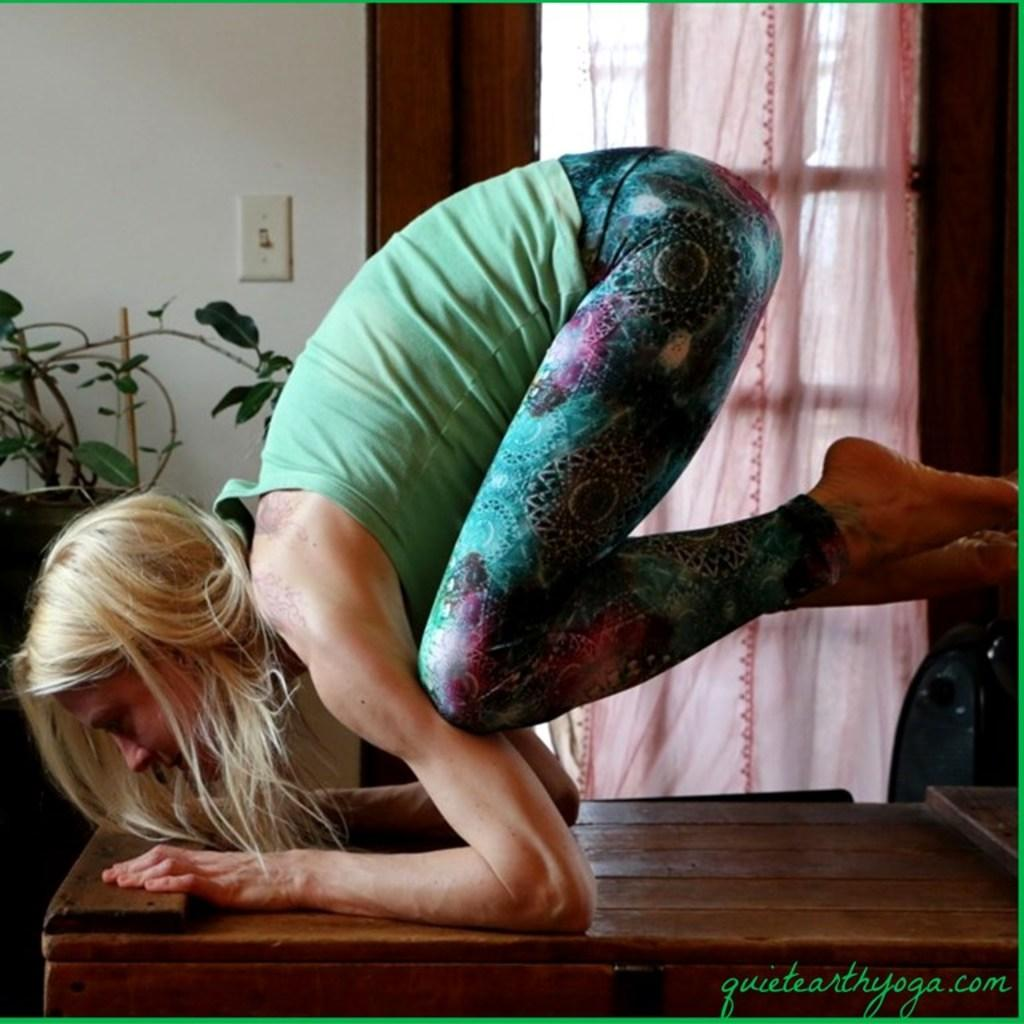Who is present in the image? There is a lady in the image. What is the lady standing on? The lady is on a wooden surface. What can be seen in the background of the image? There is a wall in the background of the image. What architectural feature is present in the image? There is a window with a curtain in the image. What type of vegetation is visible in the image? There is a plant visible in the image. What is written or displayed at the bottom of the image? There is text at the bottom of the image. Can you see any sea creatures swimming in the image? There is no sea or sea creatures present in the image. How many rings is the lady wearing on her fingers in the image? The image does not show the lady wearing any rings, so it cannot be determined how many rings she is wearing. 